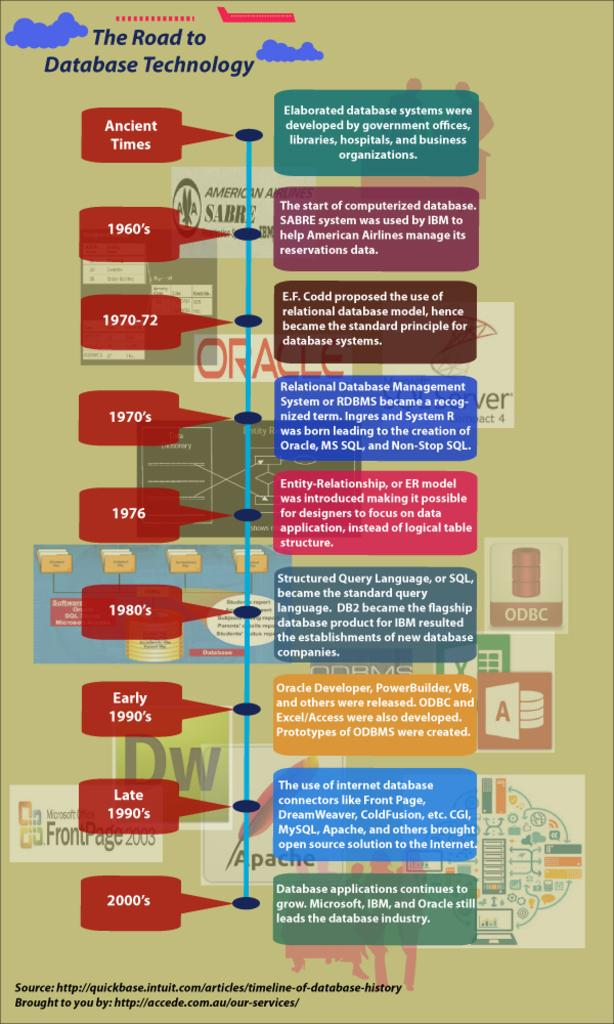Provide a one-sentence caption for the provided image. A rectangular green poster with the words "The Road to Database Technology" written on top. 